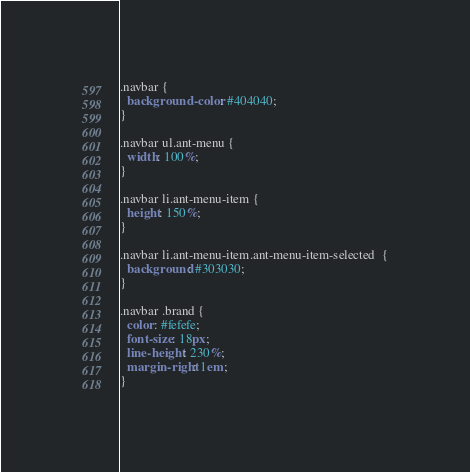<code> <loc_0><loc_0><loc_500><loc_500><_CSS_>.navbar {
  background-color: #404040;
}

.navbar ul.ant-menu {
  width: 100%;
}

.navbar li.ant-menu-item {
  height: 150%;
}

.navbar li.ant-menu-item.ant-menu-item-selected  {
  background: #303030;
}

.navbar .brand {
  color: #fefefe;
  font-size: 18px;
  line-height: 230%;
  margin-right: 1em;
}
</code> 